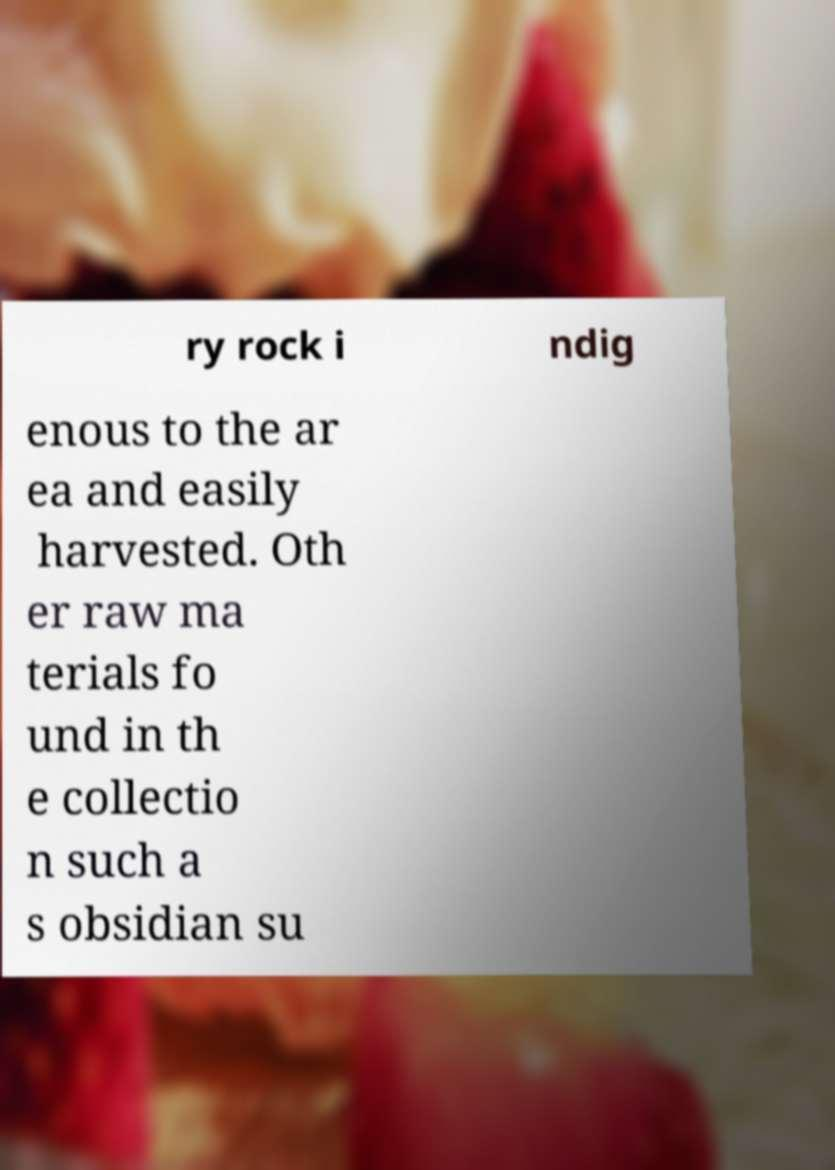For documentation purposes, I need the text within this image transcribed. Could you provide that? ry rock i ndig enous to the ar ea and easily harvested. Oth er raw ma terials fo und in th e collectio n such a s obsidian su 